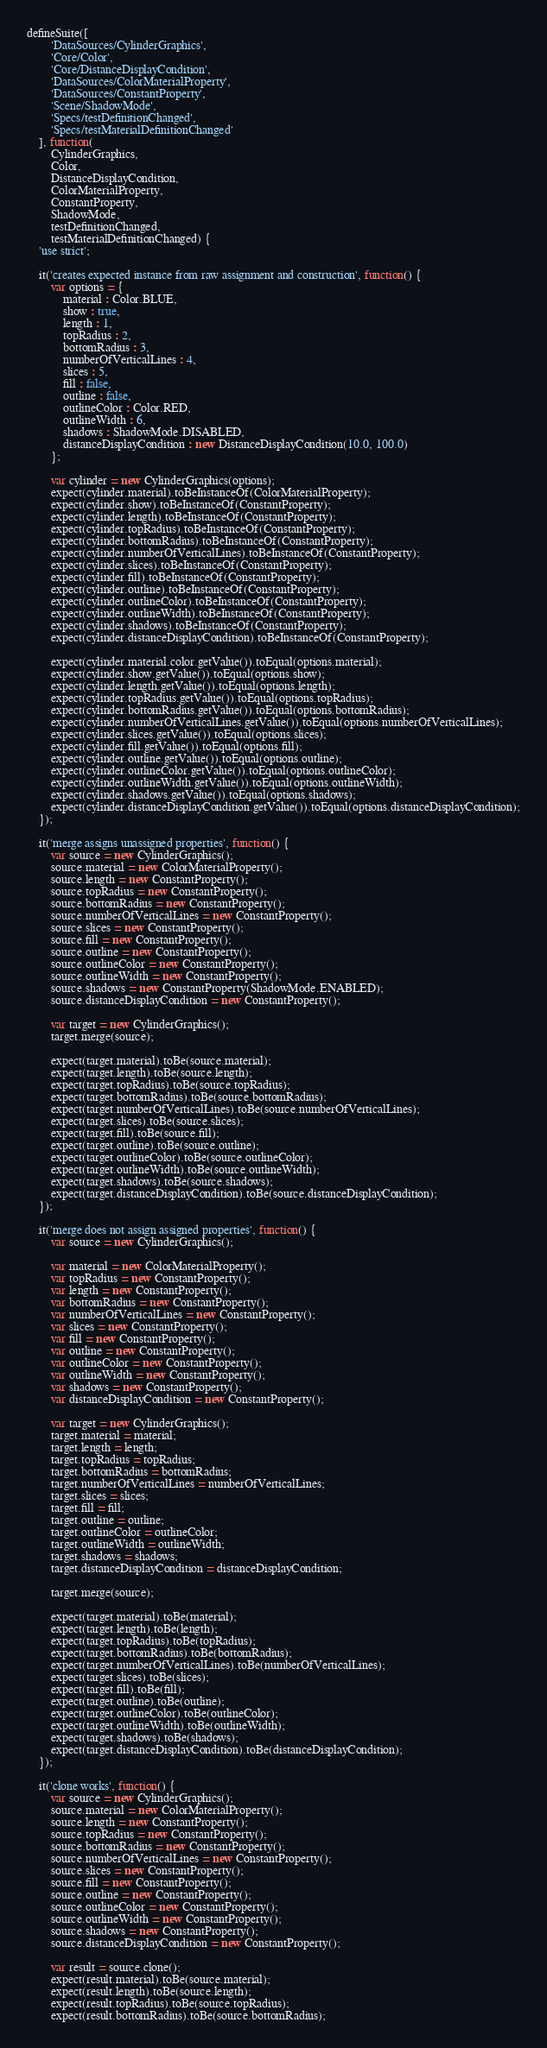<code> <loc_0><loc_0><loc_500><loc_500><_JavaScript_>defineSuite([
        'DataSources/CylinderGraphics',
        'Core/Color',
        'Core/DistanceDisplayCondition',
        'DataSources/ColorMaterialProperty',
        'DataSources/ConstantProperty',
        'Scene/ShadowMode',
        'Specs/testDefinitionChanged',
        'Specs/testMaterialDefinitionChanged'
    ], function(
        CylinderGraphics,
        Color,
        DistanceDisplayCondition,
        ColorMaterialProperty,
        ConstantProperty,
        ShadowMode,
        testDefinitionChanged,
        testMaterialDefinitionChanged) {
    'use strict';

    it('creates expected instance from raw assignment and construction', function() {
        var options = {
            material : Color.BLUE,
            show : true,
            length : 1,
            topRadius : 2,
            bottomRadius : 3,
            numberOfVerticalLines : 4,
            slices : 5,
            fill : false,
            outline : false,
            outlineColor : Color.RED,
            outlineWidth : 6,
            shadows : ShadowMode.DISABLED,
            distanceDisplayCondition : new DistanceDisplayCondition(10.0, 100.0)
        };

        var cylinder = new CylinderGraphics(options);
        expect(cylinder.material).toBeInstanceOf(ColorMaterialProperty);
        expect(cylinder.show).toBeInstanceOf(ConstantProperty);
        expect(cylinder.length).toBeInstanceOf(ConstantProperty);
        expect(cylinder.topRadius).toBeInstanceOf(ConstantProperty);
        expect(cylinder.bottomRadius).toBeInstanceOf(ConstantProperty);
        expect(cylinder.numberOfVerticalLines).toBeInstanceOf(ConstantProperty);
        expect(cylinder.slices).toBeInstanceOf(ConstantProperty);
        expect(cylinder.fill).toBeInstanceOf(ConstantProperty);
        expect(cylinder.outline).toBeInstanceOf(ConstantProperty);
        expect(cylinder.outlineColor).toBeInstanceOf(ConstantProperty);
        expect(cylinder.outlineWidth).toBeInstanceOf(ConstantProperty);
        expect(cylinder.shadows).toBeInstanceOf(ConstantProperty);
        expect(cylinder.distanceDisplayCondition).toBeInstanceOf(ConstantProperty);

        expect(cylinder.material.color.getValue()).toEqual(options.material);
        expect(cylinder.show.getValue()).toEqual(options.show);
        expect(cylinder.length.getValue()).toEqual(options.length);
        expect(cylinder.topRadius.getValue()).toEqual(options.topRadius);
        expect(cylinder.bottomRadius.getValue()).toEqual(options.bottomRadius);
        expect(cylinder.numberOfVerticalLines.getValue()).toEqual(options.numberOfVerticalLines);
        expect(cylinder.slices.getValue()).toEqual(options.slices);
        expect(cylinder.fill.getValue()).toEqual(options.fill);
        expect(cylinder.outline.getValue()).toEqual(options.outline);
        expect(cylinder.outlineColor.getValue()).toEqual(options.outlineColor);
        expect(cylinder.outlineWidth.getValue()).toEqual(options.outlineWidth);
        expect(cylinder.shadows.getValue()).toEqual(options.shadows);
        expect(cylinder.distanceDisplayCondition.getValue()).toEqual(options.distanceDisplayCondition);
    });

    it('merge assigns unassigned properties', function() {
        var source = new CylinderGraphics();
        source.material = new ColorMaterialProperty();
        source.length = new ConstantProperty();
        source.topRadius = new ConstantProperty();
        source.bottomRadius = new ConstantProperty();
        source.numberOfVerticalLines = new ConstantProperty();
        source.slices = new ConstantProperty();
        source.fill = new ConstantProperty();
        source.outline = new ConstantProperty();
        source.outlineColor = new ConstantProperty();
        source.outlineWidth = new ConstantProperty();
        source.shadows = new ConstantProperty(ShadowMode.ENABLED);
        source.distanceDisplayCondition = new ConstantProperty();

        var target = new CylinderGraphics();
        target.merge(source);

        expect(target.material).toBe(source.material);
        expect(target.length).toBe(source.length);
        expect(target.topRadius).toBe(source.topRadius);
        expect(target.bottomRadius).toBe(source.bottomRadius);
        expect(target.numberOfVerticalLines).toBe(source.numberOfVerticalLines);
        expect(target.slices).toBe(source.slices);
        expect(target.fill).toBe(source.fill);
        expect(target.outline).toBe(source.outline);
        expect(target.outlineColor).toBe(source.outlineColor);
        expect(target.outlineWidth).toBe(source.outlineWidth);
        expect(target.shadows).toBe(source.shadows);
        expect(target.distanceDisplayCondition).toBe(source.distanceDisplayCondition);
    });

    it('merge does not assign assigned properties', function() {
        var source = new CylinderGraphics();

        var material = new ColorMaterialProperty();
        var topRadius = new ConstantProperty();
        var length = new ConstantProperty();
        var bottomRadius = new ConstantProperty();
        var numberOfVerticalLines = new ConstantProperty();
        var slices = new ConstantProperty();
        var fill = new ConstantProperty();
        var outline = new ConstantProperty();
        var outlineColor = new ConstantProperty();
        var outlineWidth = new ConstantProperty();
        var shadows = new ConstantProperty();
        var distanceDisplayCondition = new ConstantProperty();

        var target = new CylinderGraphics();
        target.material = material;
        target.length = length;
        target.topRadius = topRadius;
        target.bottomRadius = bottomRadius;
        target.numberOfVerticalLines = numberOfVerticalLines;
        target.slices = slices;
        target.fill = fill;
        target.outline = outline;
        target.outlineColor = outlineColor;
        target.outlineWidth = outlineWidth;
        target.shadows = shadows;
        target.distanceDisplayCondition = distanceDisplayCondition;

        target.merge(source);

        expect(target.material).toBe(material);
        expect(target.length).toBe(length);
        expect(target.topRadius).toBe(topRadius);
        expect(target.bottomRadius).toBe(bottomRadius);
        expect(target.numberOfVerticalLines).toBe(numberOfVerticalLines);
        expect(target.slices).toBe(slices);
        expect(target.fill).toBe(fill);
        expect(target.outline).toBe(outline);
        expect(target.outlineColor).toBe(outlineColor);
        expect(target.outlineWidth).toBe(outlineWidth);
        expect(target.shadows).toBe(shadows);
        expect(target.distanceDisplayCondition).toBe(distanceDisplayCondition);
    });

    it('clone works', function() {
        var source = new CylinderGraphics();
        source.material = new ColorMaterialProperty();
        source.length = new ConstantProperty();
        source.topRadius = new ConstantProperty();
        source.bottomRadius = new ConstantProperty();
        source.numberOfVerticalLines = new ConstantProperty();
        source.slices = new ConstantProperty();
        source.fill = new ConstantProperty();
        source.outline = new ConstantProperty();
        source.outlineColor = new ConstantProperty();
        source.outlineWidth = new ConstantProperty();
        source.shadows = new ConstantProperty();
        source.distanceDisplayCondition = new ConstantProperty();

        var result = source.clone();
        expect(result.material).toBe(source.material);
        expect(result.length).toBe(source.length);
        expect(result.topRadius).toBe(source.topRadius);
        expect(result.bottomRadius).toBe(source.bottomRadius);</code> 